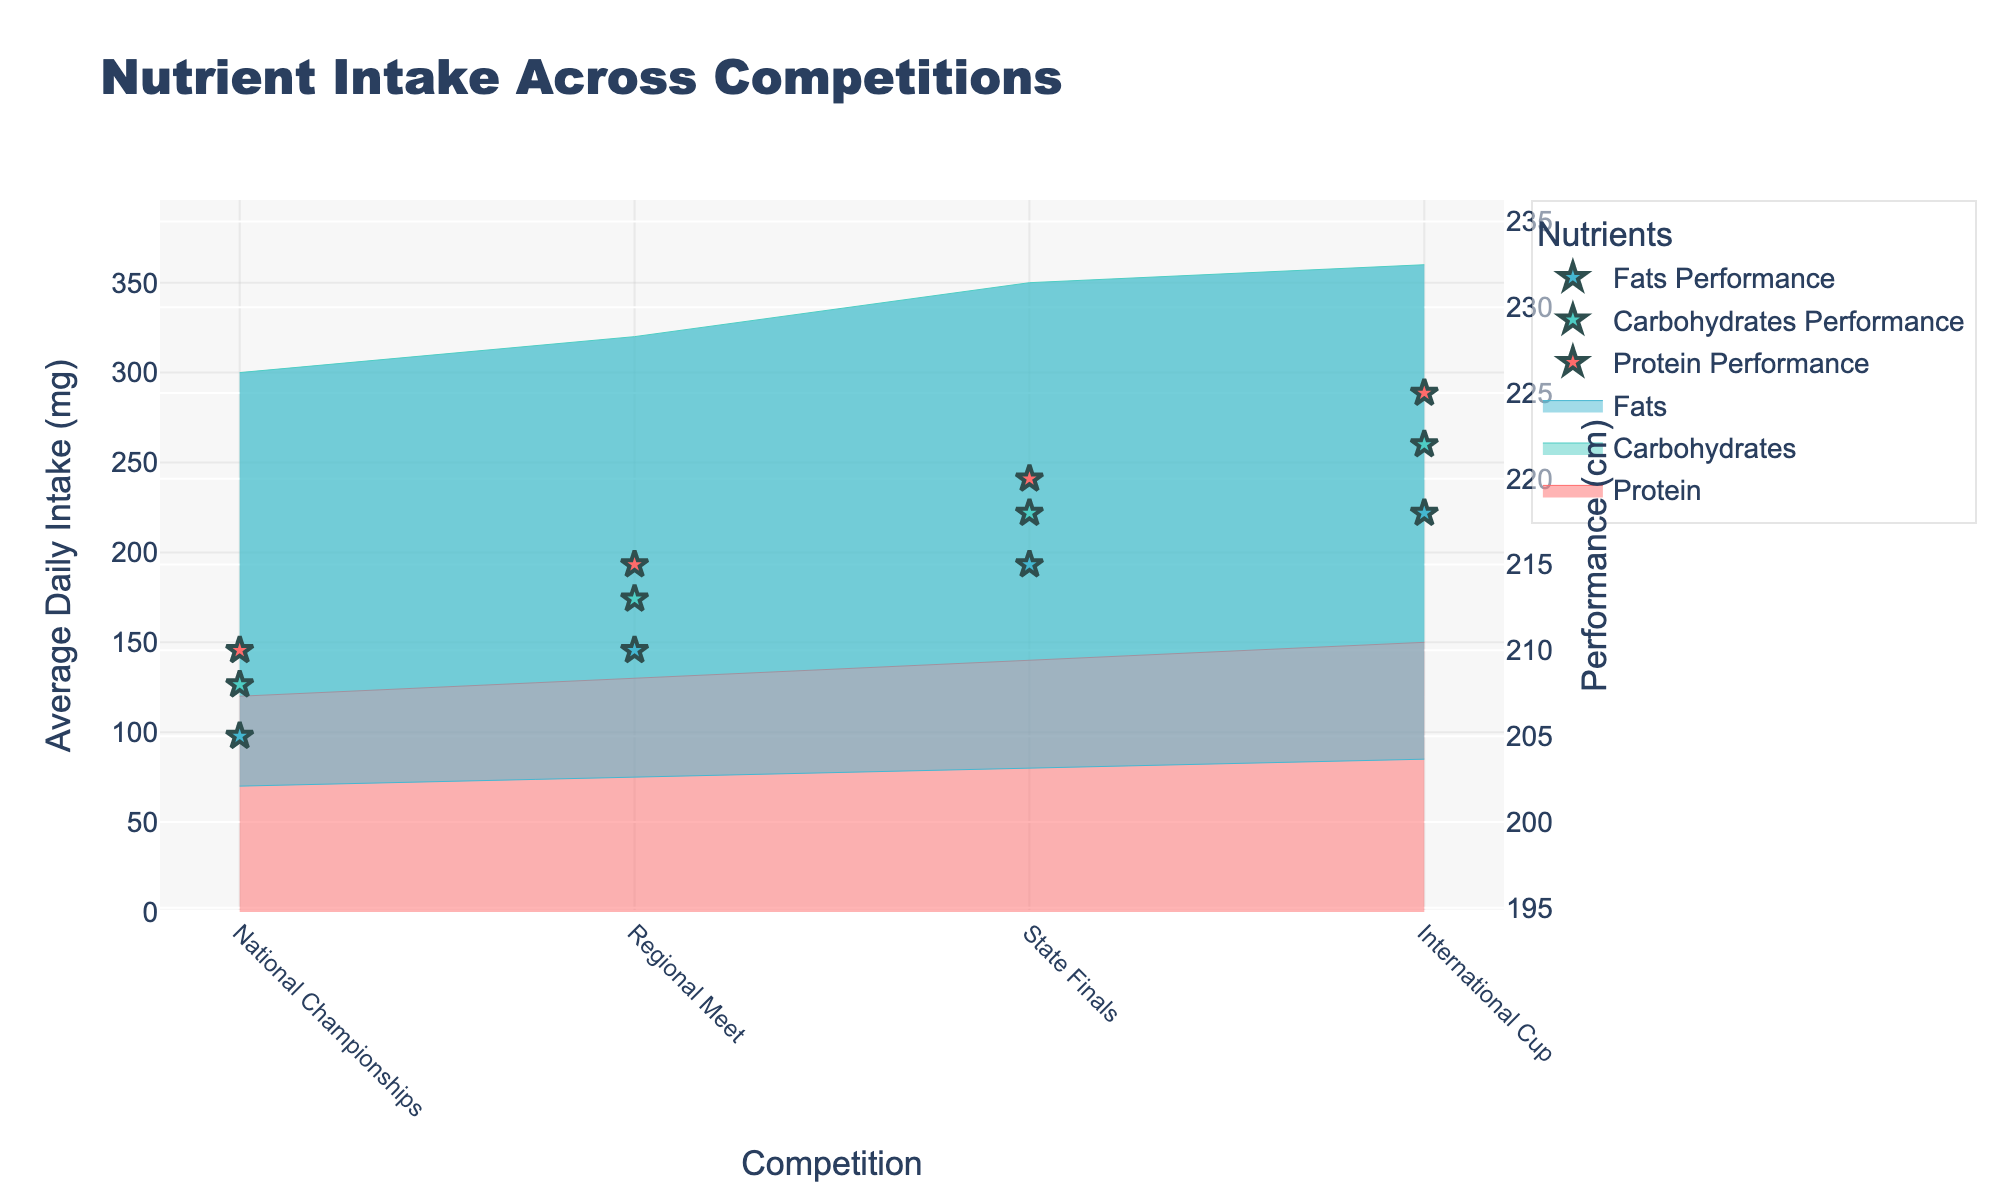What is the title of the chart? The title of the chart is located at the top and provides the main topic of the visualization. Here, it reads 'Nutrient Intake Across Competitions'.
Answer: Nutrient Intake Across Competitions How many different competitions are shown in the chart? The x-axis shows the different competitions under which data is collected. Counting the unique labels, there are four competitions: National Championships, Regional Meet, State Finals, and International Cup.
Answer: Four Which nutrient had the highest average daily intake at the International Cup? Reviewing the y-values corresponding to the 'International Cup' on the x-axis, the highest average daily intake is shown by the tallest filled area. For 'International Cup,' this is Carbohydrates with around 360 mg.
Answer: Carbohydrates What was the average daily intake of Fats during the Regional Meet? To find this, look for the Fats nutrient group at 'Regional Meet' on the x-axis. The y-value where the fills accumulate for Fats is around 75 mg.
Answer: 75 mg Which performance result is associated with the highest intake of Protein? The highest intake of Protein occurs at the International Cup (150 mg). Viewing the corresponding Performance (cm) star marker on the right y-axis, the value is 225 cm.
Answer: 225 cm How does the intake of Carbohydrates change from National Championships to State Finals? Track the Carbohydrates line from National Championships to State Finals on the x-axis. The intake increases from 300 mg at National Championships to 350 mg at State Finals.
Answer: Increases What is the difference in performance results between the National Championships and State Finals for competitors consuming Fats? Locate the Performance markers for Fats at National Championships (205 cm) and State Finals (215 cm). The difference is 215 - 205 = 10 cm.
Answer: 10 cm Which competition had the lowest performance result and what was the nutrient associated with it? Identify the lowest Performance (cm) value on the right axis. It is 205 cm at the National Championships, related to Fats intake.
Answer: National Championships, Fats At which competition did athletes have the highest performance for Carbohydrates intake, and what was the associated intake? Evaluate the Performance (cm) markers associated with Carbohydrates. The highest marker is at International Cup with 222 cm, and the intake for Carbohydrates at this competition is 360 mg.
Answer: International Cup, 360 mg What is the average protein intake across all competitions? The Protein intake values are 120, 130, 140, and 150 mg for the four competitions. Summing these gives 540 mg, and dividing by the number of competitions (4) results in an average intake of 135 mg.
Answer: 135 mg 